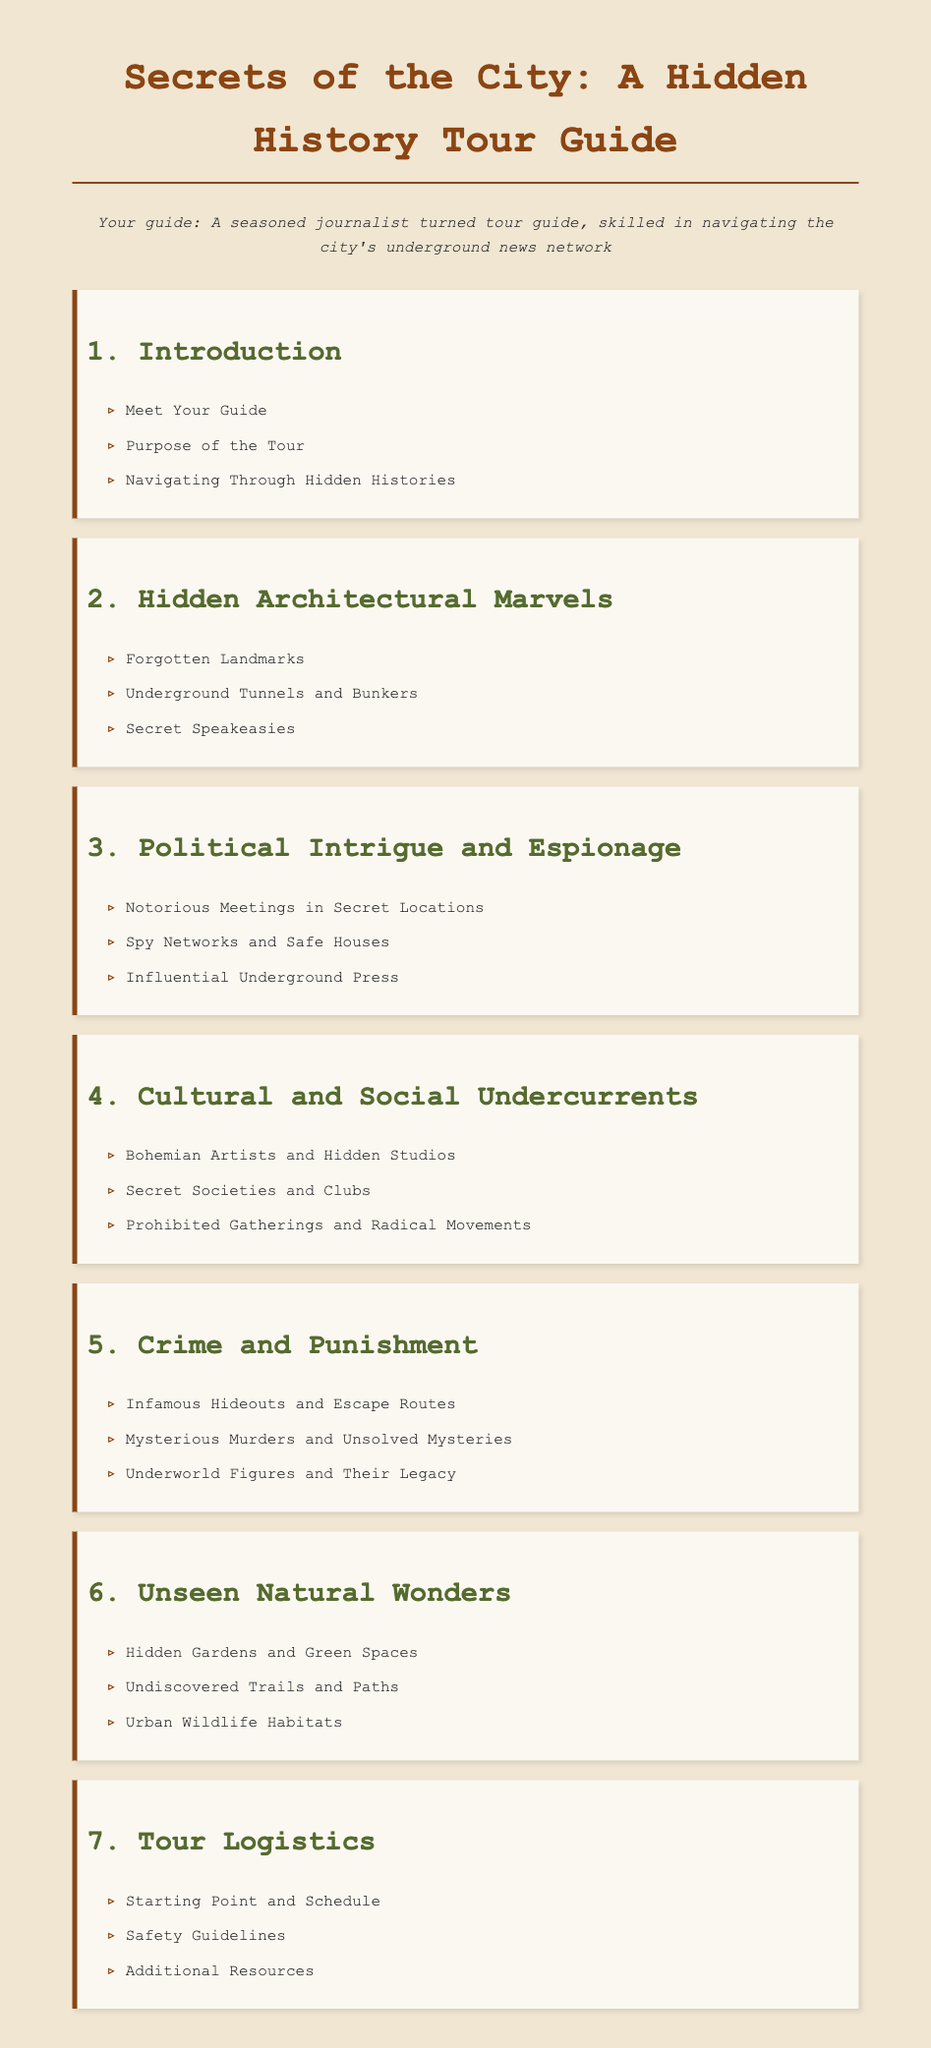What is the title of the document? The title appears prominently at the top of the rendered document.
Answer: Secrets of the City: A Hidden History Tour Guide Who is your guide? The document introduces the guide at the beginning, highlighting their background.
Answer: A seasoned journalist turned tour guide What is the first section title? The first section of the document outlines various introductory topics.
Answer: Introduction How many main sections are there in the document? The document lists seven distinct sections, each with its own focus.
Answer: 7 What is included in the 'Political Intrigue and Espionage' section? This section comprises three topics listed under its title.
Answer: Notorious Meetings in Secret Locations, Spy Networks and Safe Houses, Influential Underground Press What kind of locations does the 'Hidden Architectural Marvels' section discuss? This section focuses on various forgotten or secret locations related to architecture.
Answer: Forgotten Landmarks, Underground Tunnels and Bunkers, Secret Speakeasies What is the purpose of the tour? The document lists this purpose in the introductory section.
Answer: Purpose of the Tour What kind of themes are explored in the 'Cultural and Social Undercurrents' section? This section specifically addresses the cultural aspects of society’s hidden history.
Answer: Bohemian Artists and Hidden Studios, Secret Societies and Clubs, Prohibited Gatherings and Radical Movements 